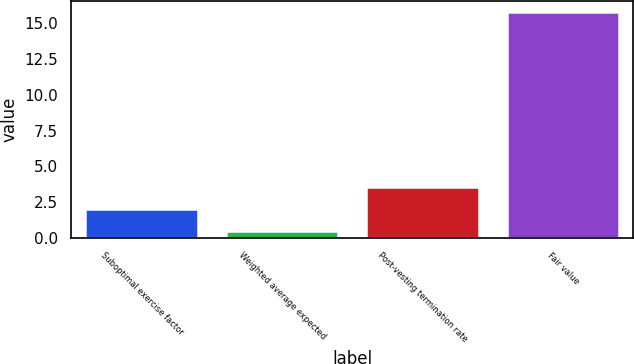Convert chart. <chart><loc_0><loc_0><loc_500><loc_500><bar_chart><fcel>Suboptimal exercise factor<fcel>Weighted average expected<fcel>Post-vesting termination rate<fcel>Fair value<nl><fcel>2.02<fcel>0.49<fcel>3.55<fcel>15.75<nl></chart> 